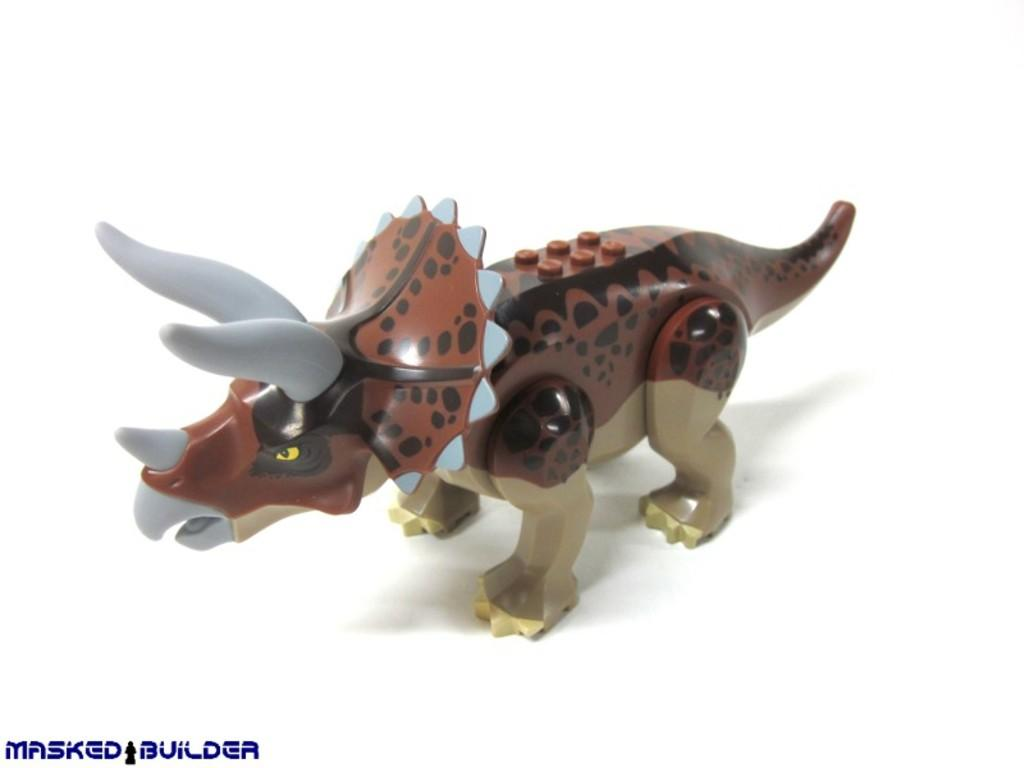What type of object is the main subject in the image? There is a toy of an animal in the image. What color is the background of the image? The background of the image is white. What else can be seen in the image besides the toy? There is text present in the image. How many wishes can be granted by the animal toy in the image? There is no indication in the image that the toy has the ability to grant wishes, so it cannot be determined from the picture. 